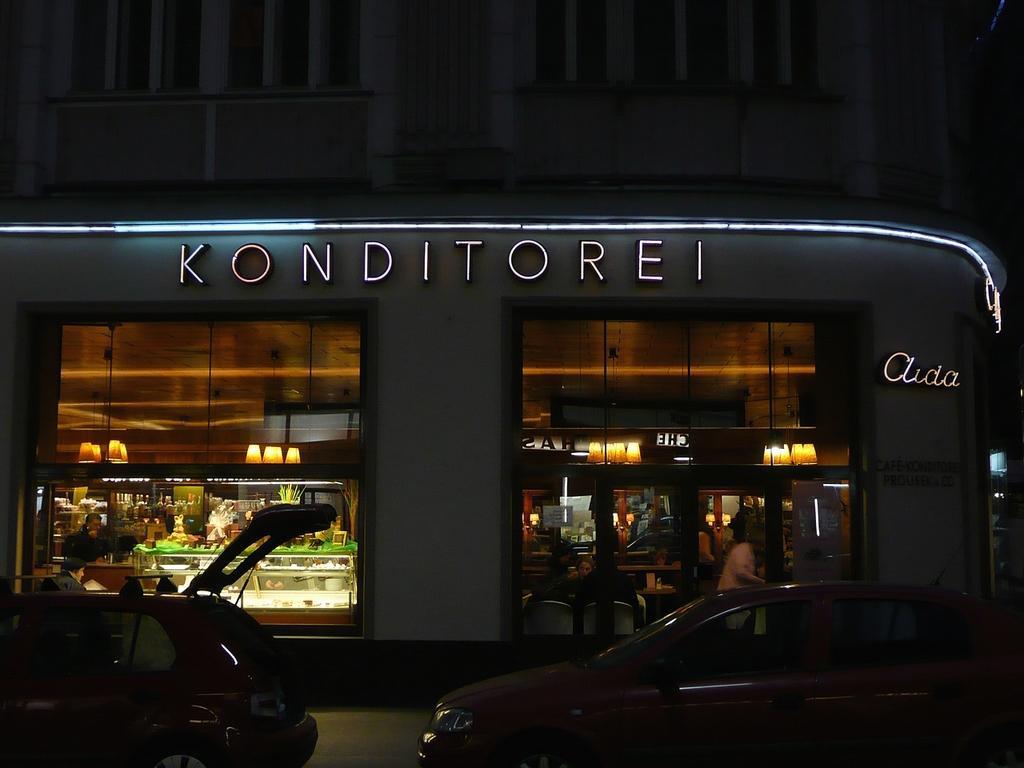Could you give a brief overview of what you see in this image? In this picture we can see vehicles on the road, beside this road we can see a building, here we can see people, name boards, lights and some objects. 